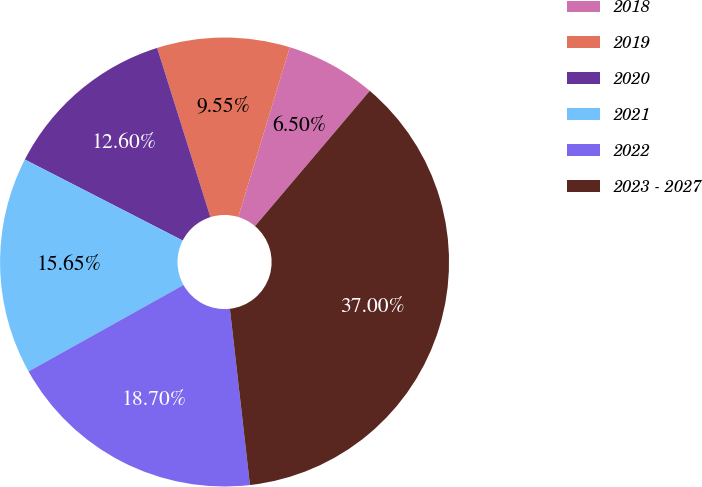Convert chart. <chart><loc_0><loc_0><loc_500><loc_500><pie_chart><fcel>2018<fcel>2019<fcel>2020<fcel>2021<fcel>2022<fcel>2023 - 2027<nl><fcel>6.5%<fcel>9.55%<fcel>12.6%<fcel>15.65%<fcel>18.7%<fcel>37.0%<nl></chart> 